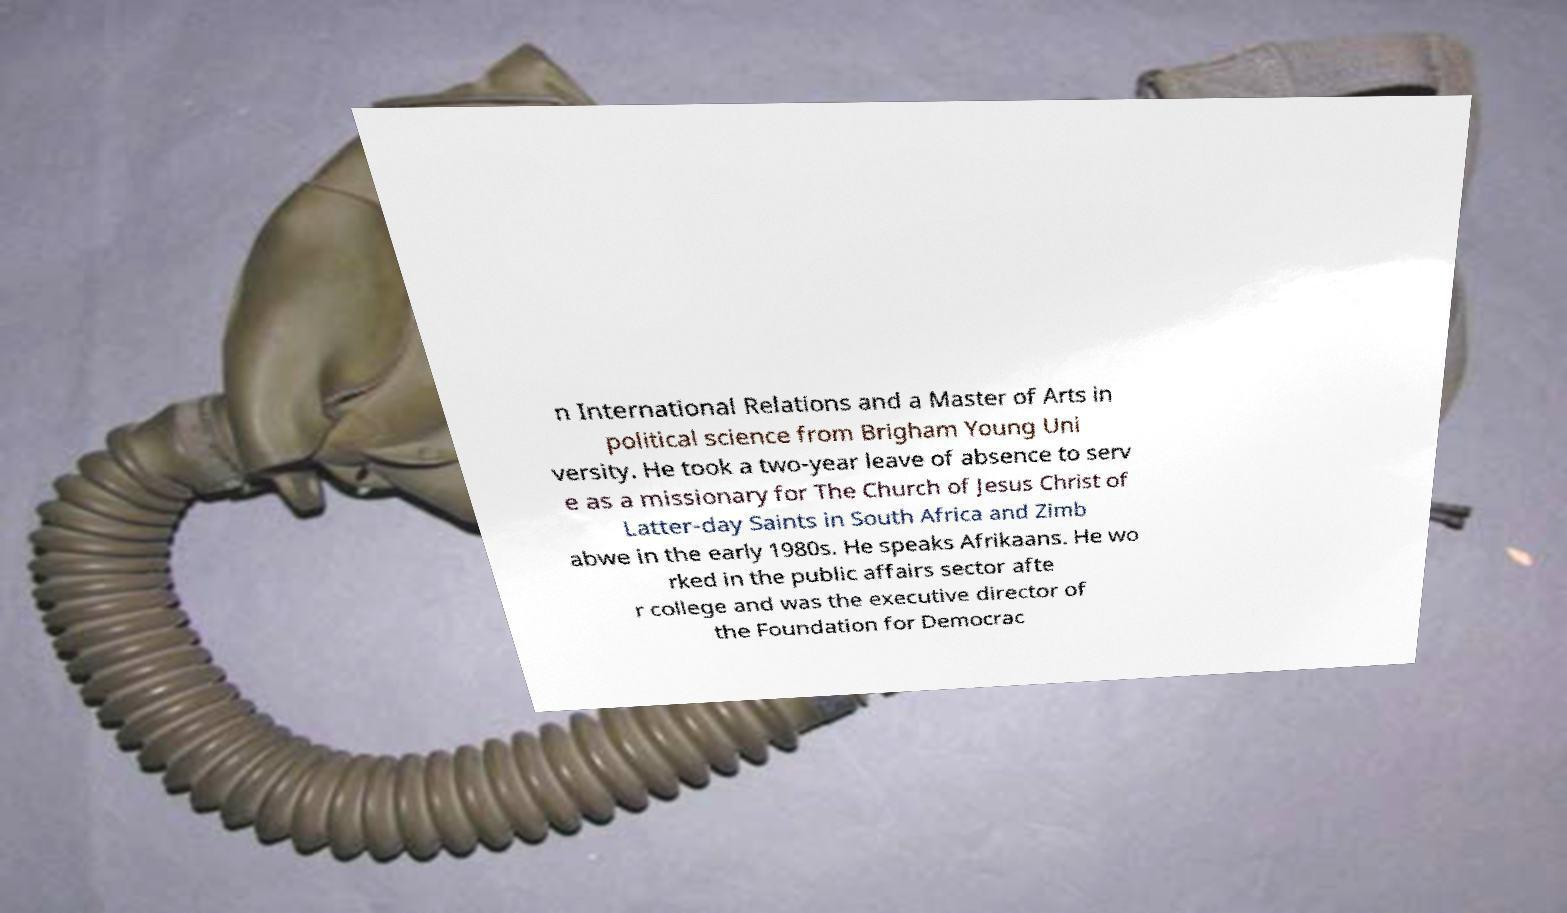Could you assist in decoding the text presented in this image and type it out clearly? n International Relations and a Master of Arts in political science from Brigham Young Uni versity. He took a two-year leave of absence to serv e as a missionary for The Church of Jesus Christ of Latter-day Saints in South Africa and Zimb abwe in the early 1980s. He speaks Afrikaans. He wo rked in the public affairs sector afte r college and was the executive director of the Foundation for Democrac 